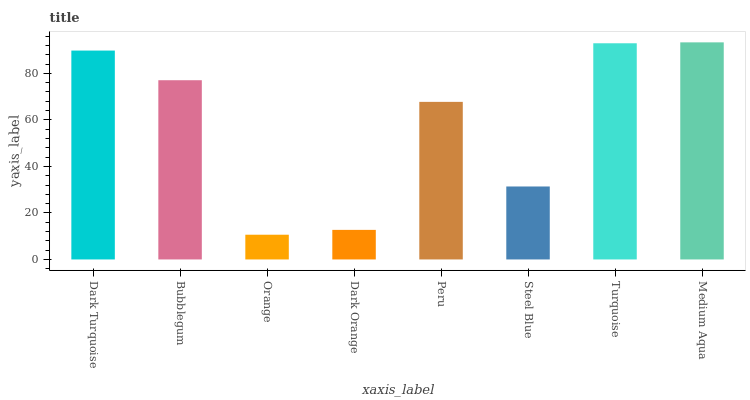Is Orange the minimum?
Answer yes or no. Yes. Is Medium Aqua the maximum?
Answer yes or no. Yes. Is Bubblegum the minimum?
Answer yes or no. No. Is Bubblegum the maximum?
Answer yes or no. No. Is Dark Turquoise greater than Bubblegum?
Answer yes or no. Yes. Is Bubblegum less than Dark Turquoise?
Answer yes or no. Yes. Is Bubblegum greater than Dark Turquoise?
Answer yes or no. No. Is Dark Turquoise less than Bubblegum?
Answer yes or no. No. Is Bubblegum the high median?
Answer yes or no. Yes. Is Peru the low median?
Answer yes or no. Yes. Is Peru the high median?
Answer yes or no. No. Is Steel Blue the low median?
Answer yes or no. No. 